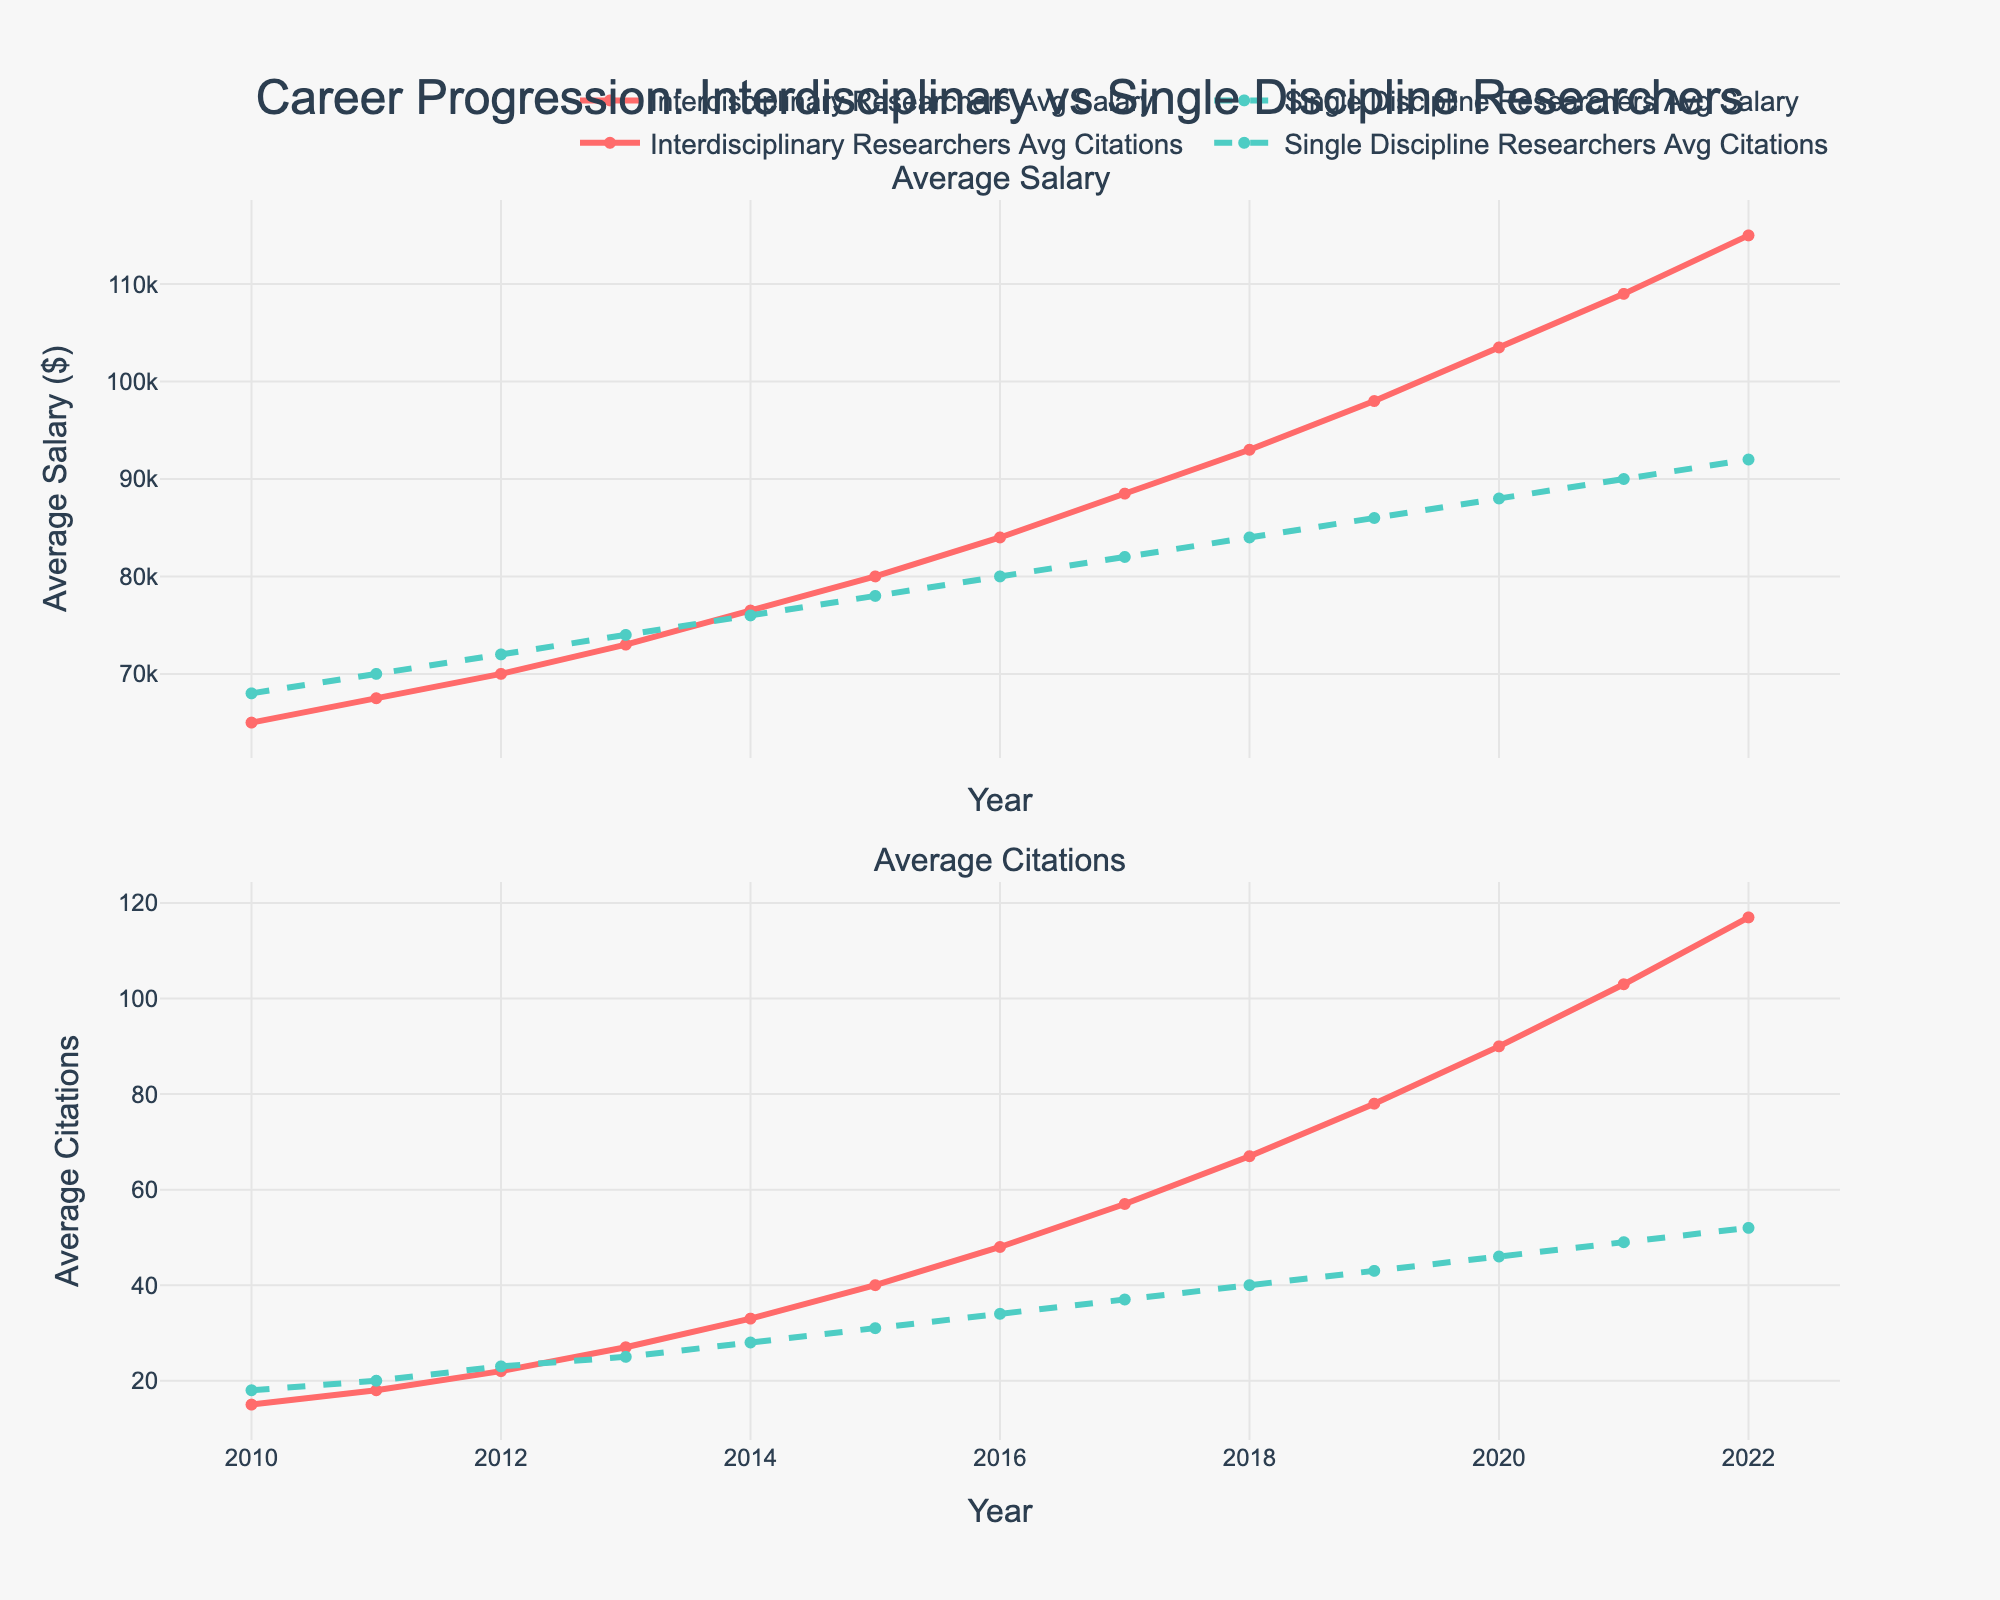what is the difference in average salary between interdisciplinary and single discipline researchers in 2022? To find the difference, subtract the 2022 average salary of single discipline researchers from that of interdisciplinary researchers: 115,000 - 92,000 = 23,000
Answer: 23,000 Which group saw a higher increase in average citations from 2010 to 2022? Calculate the increase for each group: Interdisciplinary research citations increased from 15 to 117, which is an increase of 102. Single discipline research citations increased from 18 to 52, which is an increase of 34. Therefore, interdisciplinary researchers saw a higher increase.
Answer: Interdisciplinary researchers In which year did interdisciplinary researchers surpass single discipline researchers in average salary? Track the lines on the salary subplot until the red (interdisciplinary) line goes above the green (single discipline) line. This occurs in the year 2014.
Answer: 2014 By how much did the average salary for single-discipline researchers increase from 2010 to 2022? Subtract the 2010 average salary from the 2022 average salary for single discipline researchers: 92,000 - 68,000 = 24,000
Answer: 24,000 How do the trends in average salary compare between the two groups? The average salary for both groups shows an upward trend over the years. However, the growth rate for interdisciplinary researchers is higher as they start below single discipline researchers and end up surpassing them around 2014 and continue to lead thereafter.
Answer: Interdisciplinary researchers have a higher growth rate In which year did interdisciplinary researchers reach an average citation count of exactly 48? Locate the point on the citation subplot where the blue (interdisciplinary) line intersects with the citation value of 48. This happens in 2016.
Answer: 2016 What visual attribute is used to differentiate between the groups in the figure? Color and line style are used: red and solid line for interdisciplinary researchers, and green and dashed line for single discipline researchers.
Answer: Color and line style How much more citations did interdisciplinary researchers have compared to single discipline researchers in 2020? Subtract the average citations of single discipline researchers from interdisciplinary researchers for the year 2020: 90 - 46 = 44
Answer: 44 Are there any years where single discipline researchers have higher average salaries but fewer citations than interdisciplinary researchers? Identify the years where the green dashed line (single discipline salary) is above the red solid line (interdisciplinary salary) and simultaneously the green dashed line (single discipline citations) is below the blue solid line (interdisciplinary citations). This occurs in years 2010 to 2013.
Answer: 2010 to 2013 